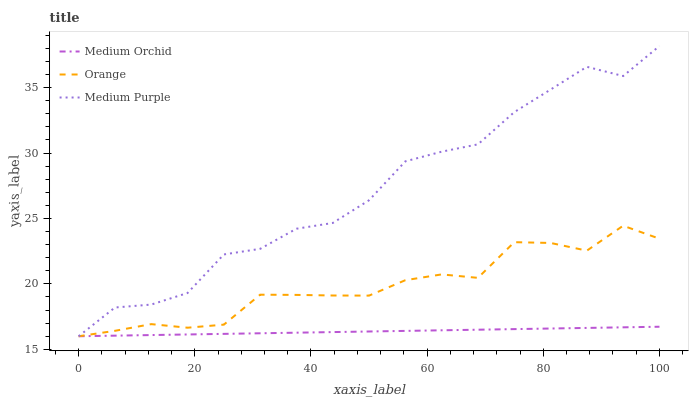Does Medium Orchid have the minimum area under the curve?
Answer yes or no. Yes. Does Medium Purple have the maximum area under the curve?
Answer yes or no. Yes. Does Medium Purple have the minimum area under the curve?
Answer yes or no. No. Does Medium Orchid have the maximum area under the curve?
Answer yes or no. No. Is Medium Orchid the smoothest?
Answer yes or no. Yes. Is Medium Purple the roughest?
Answer yes or no. Yes. Is Medium Purple the smoothest?
Answer yes or no. No. Is Medium Orchid the roughest?
Answer yes or no. No. Does Orange have the lowest value?
Answer yes or no. Yes. Does Medium Purple have the highest value?
Answer yes or no. Yes. Does Medium Orchid have the highest value?
Answer yes or no. No. Does Orange intersect Medium Orchid?
Answer yes or no. Yes. Is Orange less than Medium Orchid?
Answer yes or no. No. Is Orange greater than Medium Orchid?
Answer yes or no. No. 